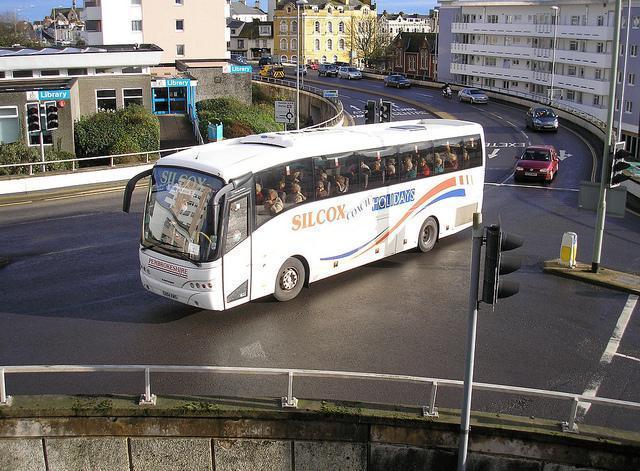How many buses are in the photo?
Give a very brief answer. 1. 